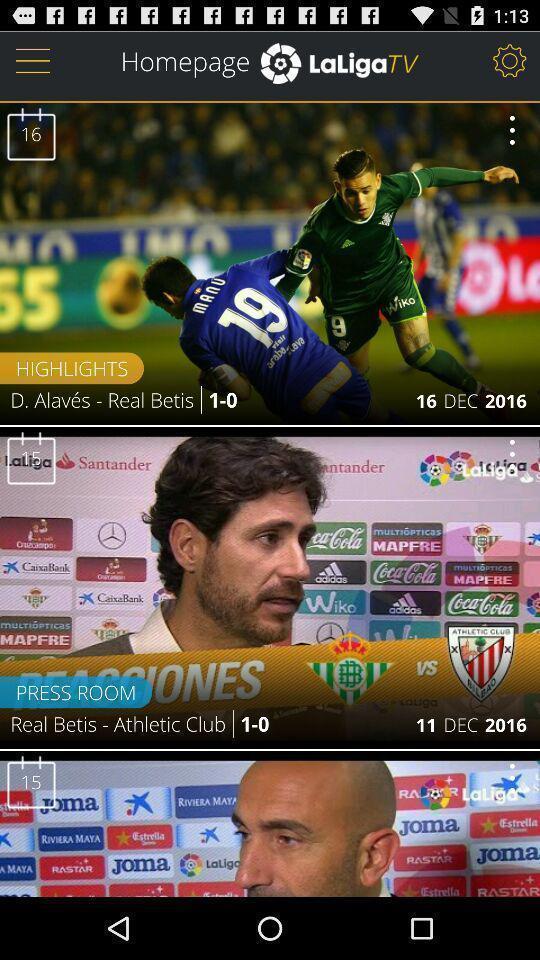Please provide a description for this image. Screen page of a sports app. 